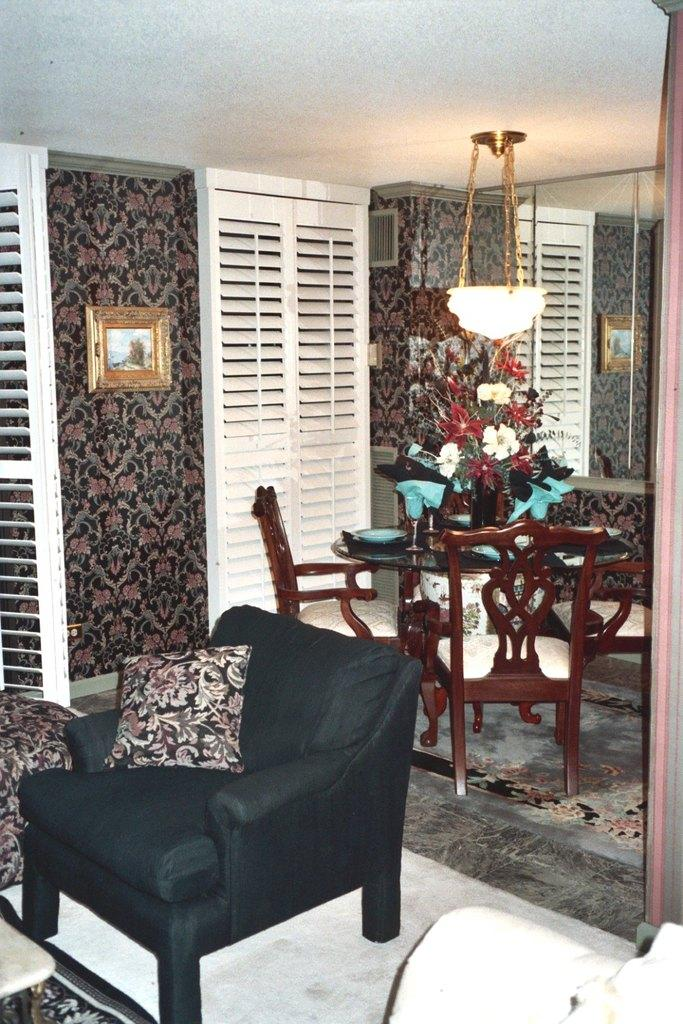What type of furniture is present in the image? There are chairs and a table in the image. What decorative item can be seen on the table? There is a flower bouquet on the table in the image. What can be seen in the background of the image? There is a wall and a roof in the background of the image. Can you tell me how many animals are in the zoo in the image? There is no zoo present in the image; it features chairs, a table, a flower bouquet, and a background with a wall and roof. What is the cause of the head bursting in the image? There is no head or bursting event present in the image. 